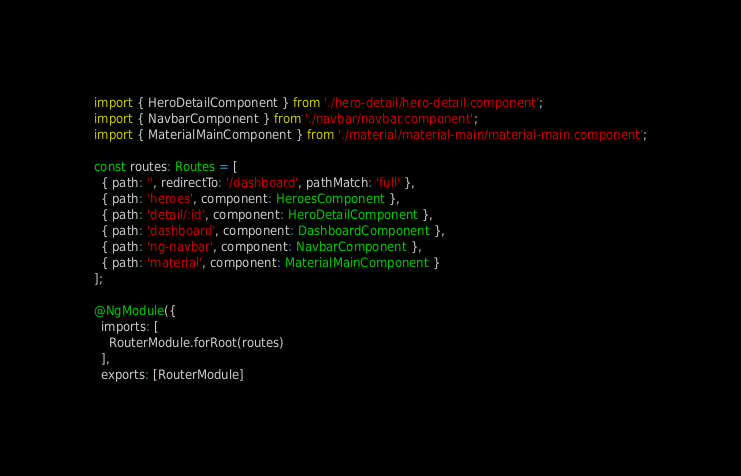Convert code to text. <code><loc_0><loc_0><loc_500><loc_500><_TypeScript_>import { HeroDetailComponent } from './hero-detail/hero-detail.component';
import { NavbarComponent } from './navbar/navbar.component';
import { MaterialMainComponent } from './material/material-main/material-main.component';

const routes: Routes = [
  { path: '', redirectTo: '/dashboard', pathMatch: 'full' },
  { path: 'heroes', component: HeroesComponent },
  { path: 'detail/:id', component: HeroDetailComponent },
  { path: 'dashboard', component: DashboardComponent },
  { path: 'ng-navbar', component: NavbarComponent },
  { path: 'material', component: MaterialMainComponent }
];

@NgModule({
  imports: [
    RouterModule.forRoot(routes)
  ],
  exports: [RouterModule]</code> 